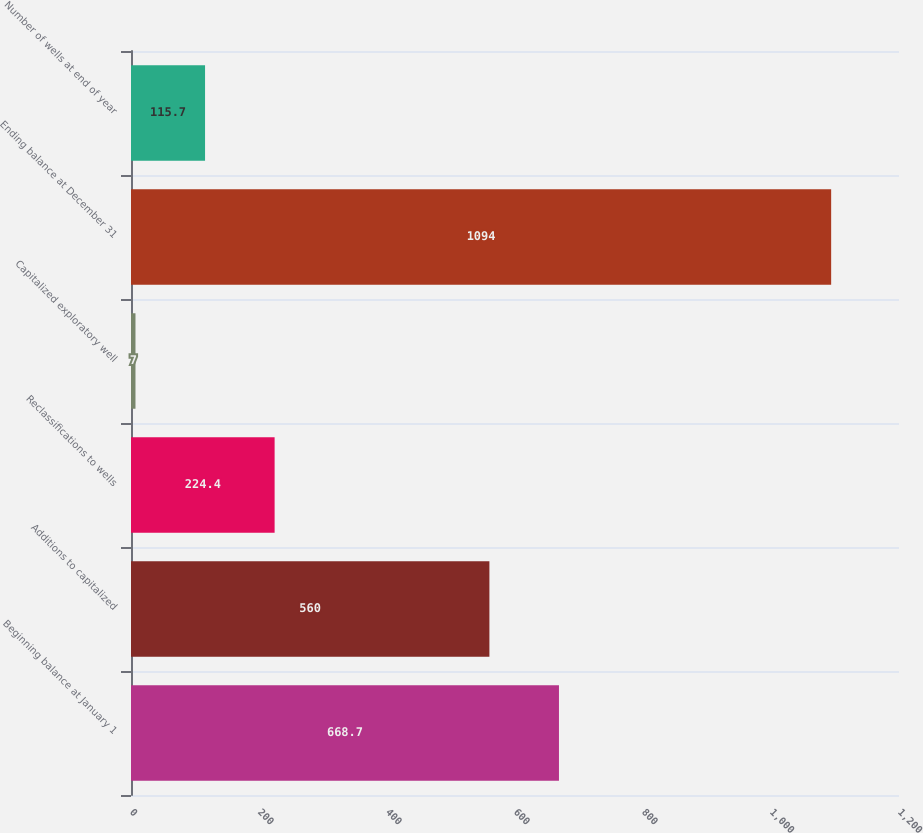<chart> <loc_0><loc_0><loc_500><loc_500><bar_chart><fcel>Beginning balance at January 1<fcel>Additions to capitalized<fcel>Reclassifications to wells<fcel>Capitalized exploratory well<fcel>Ending balance at December 31<fcel>Number of wells at end of year<nl><fcel>668.7<fcel>560<fcel>224.4<fcel>7<fcel>1094<fcel>115.7<nl></chart> 